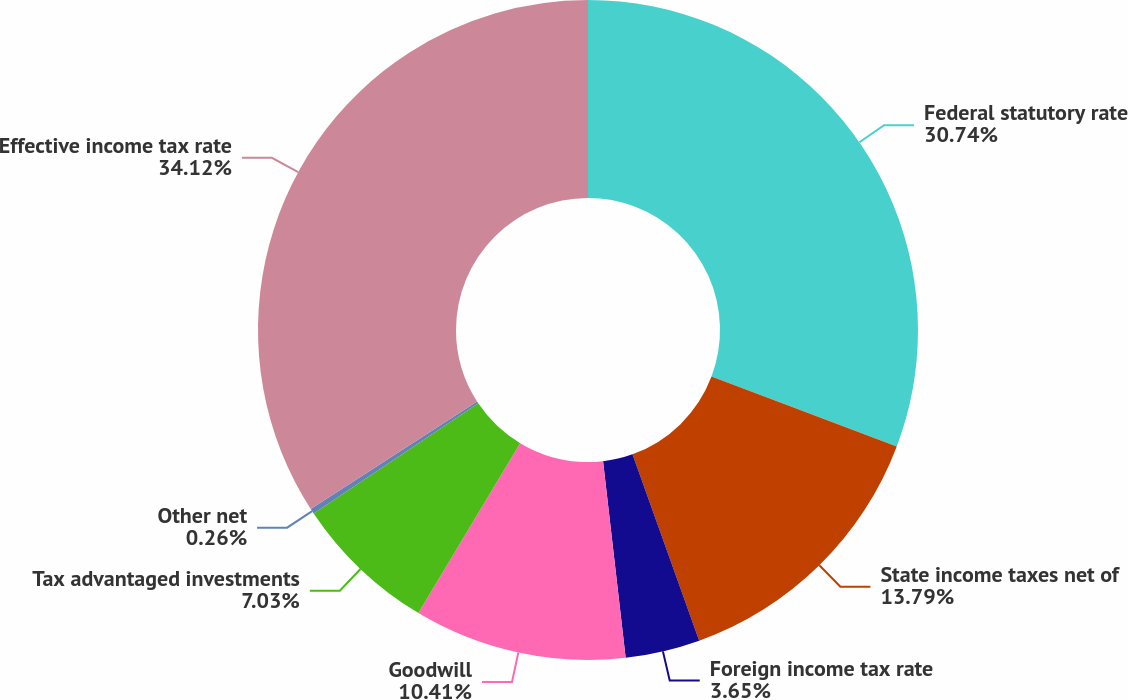Convert chart to OTSL. <chart><loc_0><loc_0><loc_500><loc_500><pie_chart><fcel>Federal statutory rate<fcel>State income taxes net of<fcel>Foreign income tax rate<fcel>Goodwill<fcel>Tax advantaged investments<fcel>Other net<fcel>Effective income tax rate<nl><fcel>30.74%<fcel>13.79%<fcel>3.65%<fcel>10.41%<fcel>7.03%<fcel>0.26%<fcel>34.12%<nl></chart> 